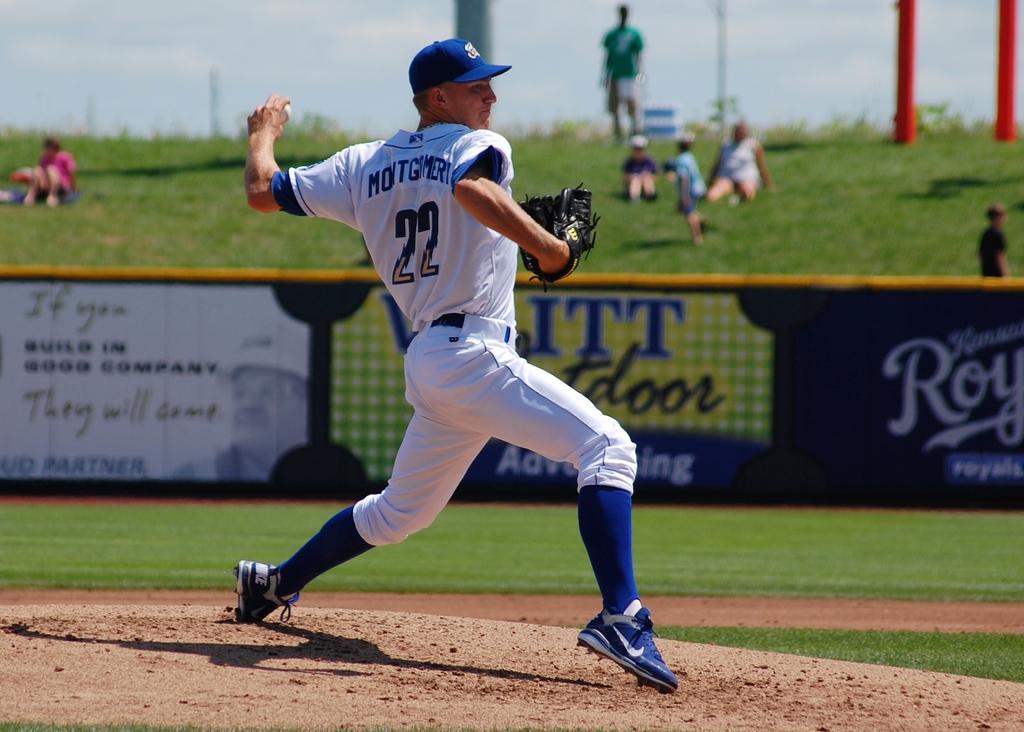What does the number 22 mean?
Offer a very short reply. Player number. 